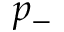<formula> <loc_0><loc_0><loc_500><loc_500>p _ { - }</formula> 